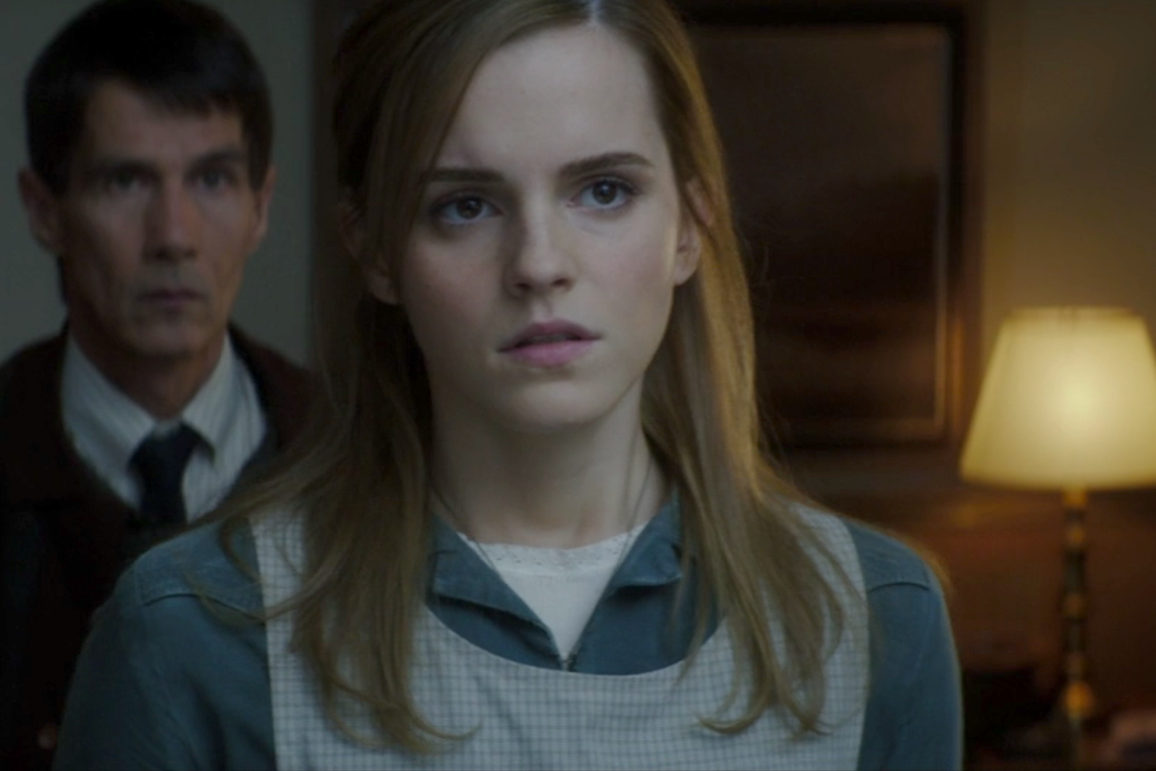What if this image is from a psychological thriller? Describe the build-up to this exact point. In a psychological thriller, this image captures a climactic moment where the protagonist, a woman working as a forensic psychologist, has just pieced together the identity of a cunning serial manipulator. The dimly lit room reflects the cold, calculating nature of the antagonist - the man in the background. He had been posing as a supportive colleague, but his true intentions are now clear. The protagonist's wide-eyed expression is a mix of fear and determination as she realizes the danger she's in. The man's presence behind her is menacing, his gaze cold and predatory, indicating that he knows his cover has been blown. The warmth of the lamp creates a dissonant sense of false security, highlighting the underlying tension as the protagonist decides her next move to outwit him. 